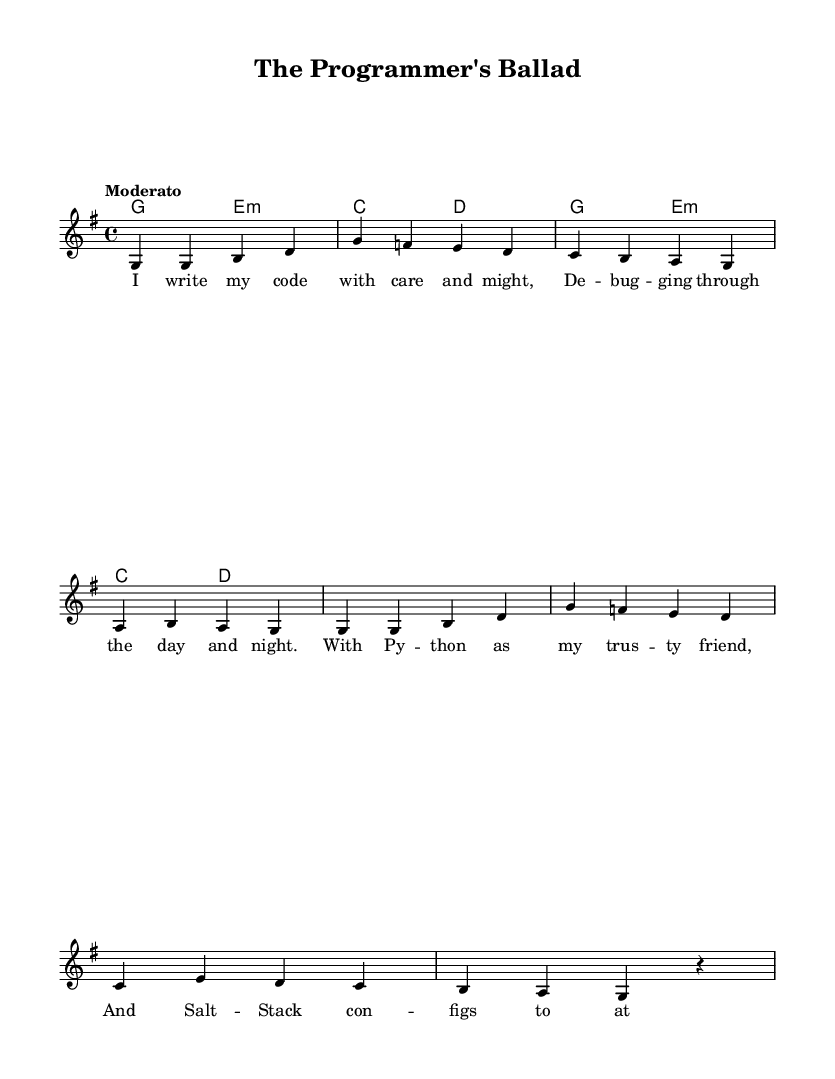What is the key signature of this music? The key signature is G major, which has one sharp (F#).
Answer: G major What is the time signature of the piece? The time signature is 4/4, which means there are four beats in a measure and the quarter note gets one beat.
Answer: 4/4 What is the tempo marking for this piece? The tempo marking is "Moderato," indicating a moderately paced tempo.
Answer: Moderato How many measures are in the melody? The melody comprises eight measures in total.
Answer: Eight What instruments are indicated in the score? The score indicates a voice for melody and chord names for harmony, implying a folk-style arrangement suitable for singing.
Answer: Voice and Chord Names Which programming language is mentioned in the lyrics? The lyrics reference Python as a trusted programming friend.
Answer: Python What musical device is used in the chord progression? The chord progression uses a basic harmonic structure with alternating major and minor chords common in folk music.
Answer: Chord progression 